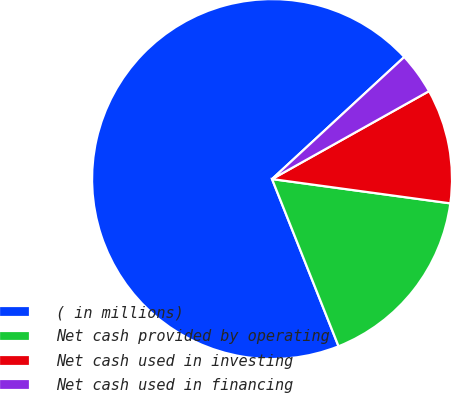Convert chart. <chart><loc_0><loc_0><loc_500><loc_500><pie_chart><fcel>( in millions)<fcel>Net cash provided by operating<fcel>Net cash used in investing<fcel>Net cash used in financing<nl><fcel>69.16%<fcel>16.82%<fcel>10.28%<fcel>3.74%<nl></chart> 